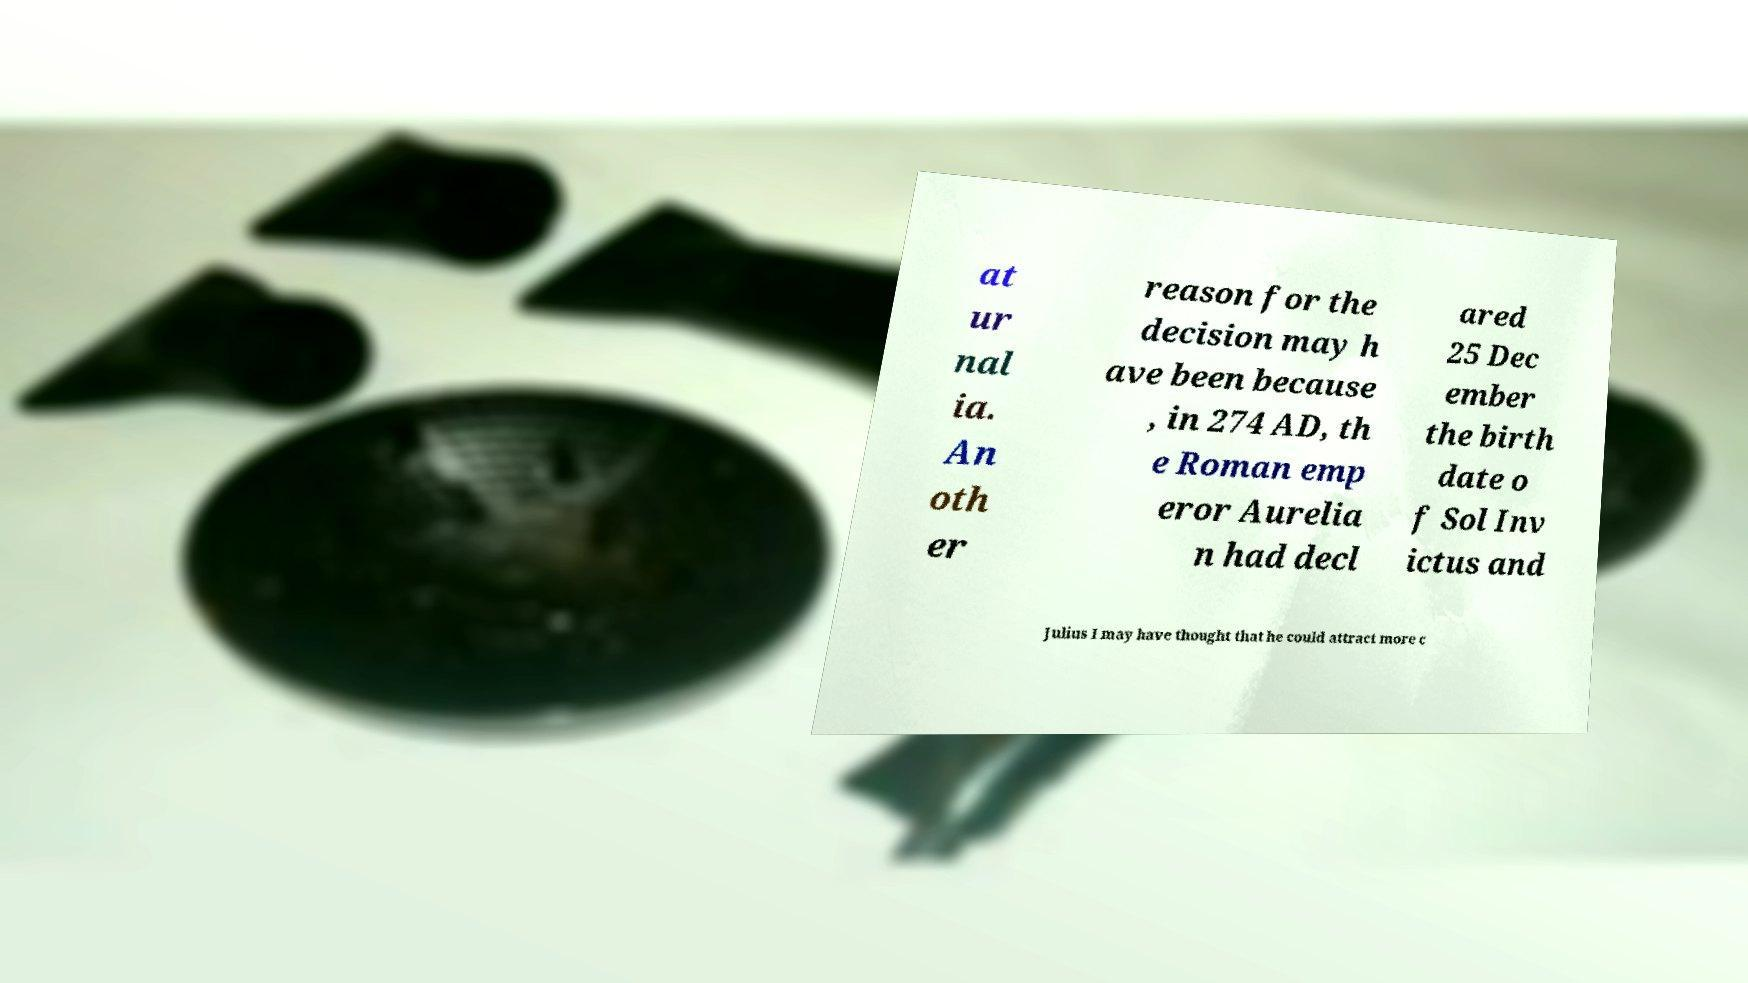I need the written content from this picture converted into text. Can you do that? at ur nal ia. An oth er reason for the decision may h ave been because , in 274 AD, th e Roman emp eror Aurelia n had decl ared 25 Dec ember the birth date o f Sol Inv ictus and Julius I may have thought that he could attract more c 